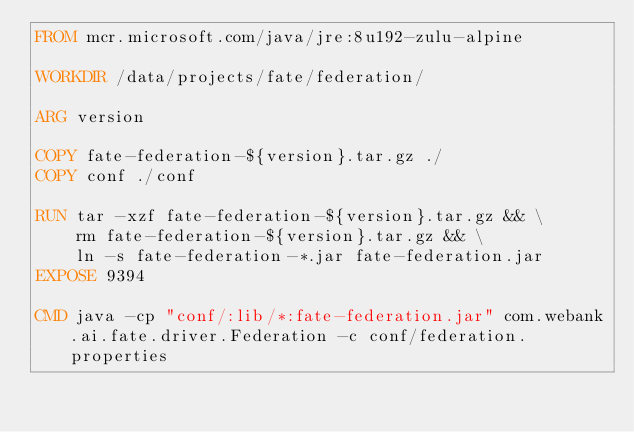Convert code to text. <code><loc_0><loc_0><loc_500><loc_500><_Dockerfile_>FROM mcr.microsoft.com/java/jre:8u192-zulu-alpine

WORKDIR /data/projects/fate/federation/

ARG version

COPY fate-federation-${version}.tar.gz ./
COPY conf ./conf

RUN tar -xzf fate-federation-${version}.tar.gz && \
    rm fate-federation-${version}.tar.gz && \
    ln -s fate-federation-*.jar fate-federation.jar
EXPOSE 9394

CMD java -cp "conf/:lib/*:fate-federation.jar" com.webank.ai.fate.driver.Federation -c conf/federation.properties

</code> 